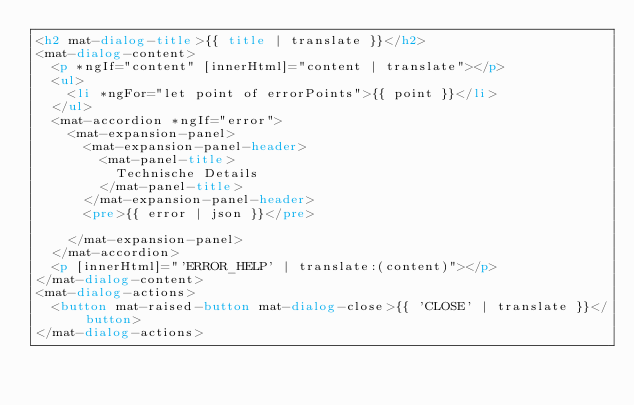<code> <loc_0><loc_0><loc_500><loc_500><_HTML_><h2 mat-dialog-title>{{ title | translate }}</h2>
<mat-dialog-content>
  <p *ngIf="content" [innerHtml]="content | translate"></p>
  <ul>
    <li *ngFor="let point of errorPoints">{{ point }}</li>
  </ul>
  <mat-accordion *ngIf="error">
    <mat-expansion-panel>
      <mat-expansion-panel-header>
        <mat-panel-title>
          Technische Details
        </mat-panel-title>
      </mat-expansion-panel-header>
      <pre>{{ error | json }}</pre>

    </mat-expansion-panel>
  </mat-accordion>
  <p [innerHtml]="'ERROR_HELP' | translate:(content)"></p>
</mat-dialog-content>
<mat-dialog-actions>
  <button mat-raised-button mat-dialog-close>{{ 'CLOSE' | translate }}</button>
</mat-dialog-actions>
</code> 